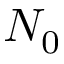<formula> <loc_0><loc_0><loc_500><loc_500>N _ { 0 }</formula> 